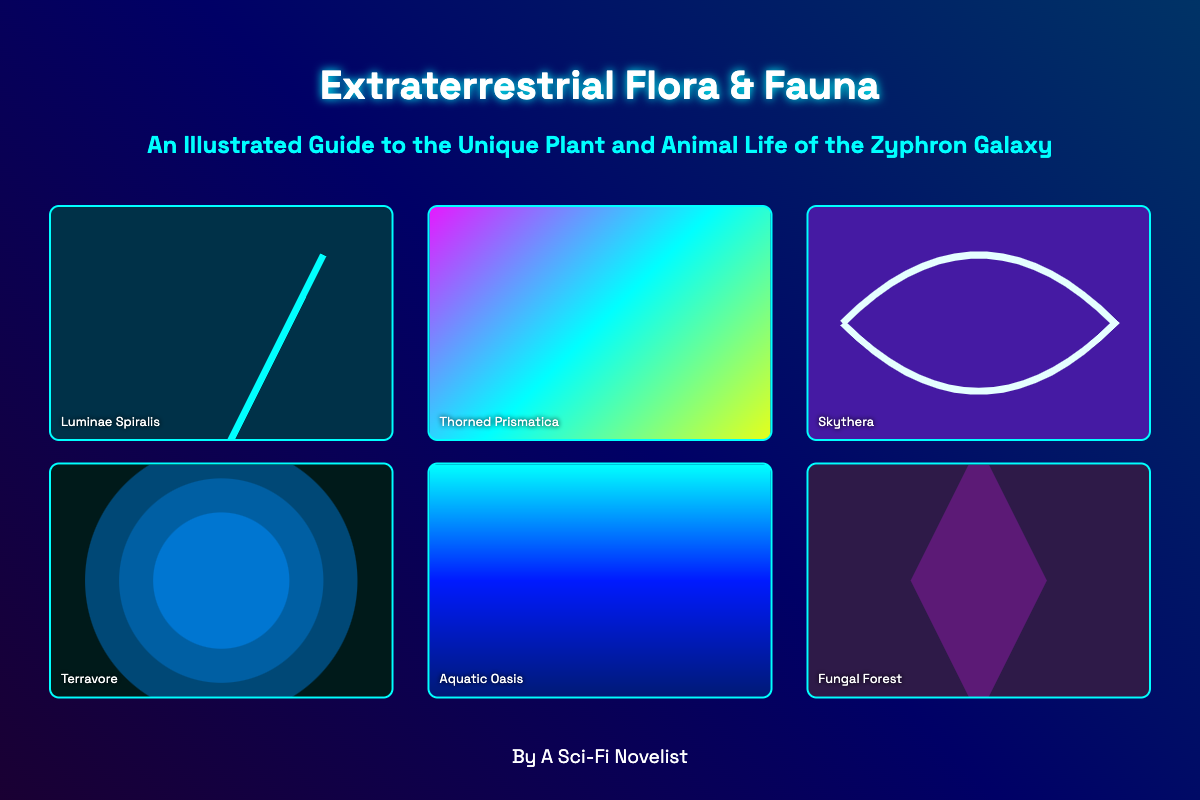What is the title of the book? The title is prominently displayed at the top of the cover.
Answer: Extraterrestrial Flora & Fauna Who is the author of the book? The author's name is mentioned at the bottom of the cover.
Answer: A Sci-Fi Novelist What is the subtitle of the book? The subtitle provides additional context about the content of the book.
Answer: An Illustrated Guide to the Unique Plant and Animal Life of the Zyphron Galaxy How many illustrated elements are shown on the cover? The cover features a total of six illustrated elements.
Answer: 6 What is the name of the illustrated element with spirals? The name is embedded within the visual representation of the element.
Answer: Luminae Spiralis Which illustrated element includes a gradient of pink and cyan? The color gradient indicates a specific illustrated element among the options.
Answer: Thorned Prismatica What is the color scheme used for the background of the book cover? The book cover features a gradient background effect with multiple colors.
Answer: Blue and purple gradient Which ecological type is represented by "Fungal Forest"? This name is directly associated with a specific style of plant life depicted on the cover.
Answer: Fungal ecology What color dominates the "Aquatic Oasis" element? The visual representation indicates the primary color of the element.
Answer: Blue 